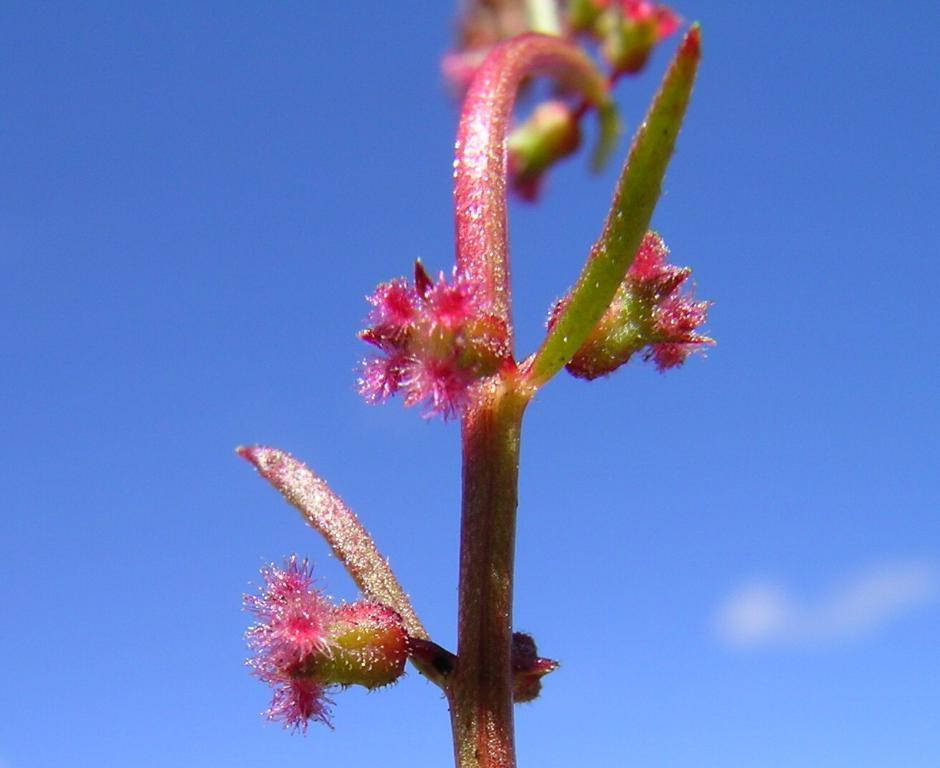What type of living organism can be seen in the image? There is a plant in the image. What is visible in the background of the image? The background of the image includes a blue sky. What type of waves can be seen crashing on the shore in the image? There are no waves or shore present in the image; it features a plant and a blue sky. How is the knot tied around the plant in the image? There is no knot present around the plant in the image. 